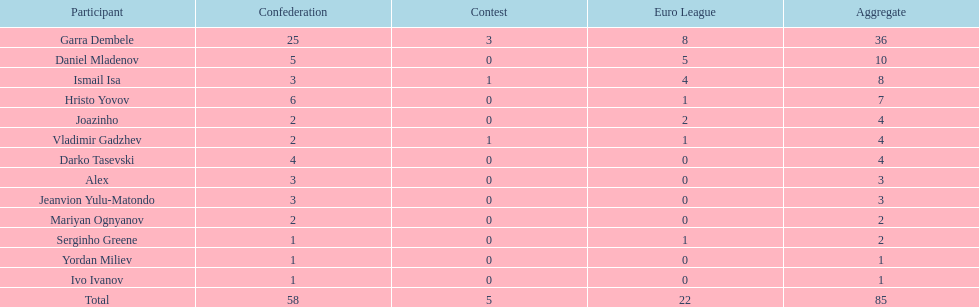How many players did not score a goal in cup play? 10. Give me the full table as a dictionary. {'header': ['Participant', 'Confederation', 'Contest', 'Euro League', 'Aggregate'], 'rows': [['Garra Dembele', '25', '3', '8', '36'], ['Daniel Mladenov', '5', '0', '5', '10'], ['Ismail Isa', '3', '1', '4', '8'], ['Hristo Yovov', '6', '0', '1', '7'], ['Joazinho', '2', '0', '2', '4'], ['Vladimir Gadzhev', '2', '1', '1', '4'], ['Darko Tasevski', '4', '0', '0', '4'], ['Alex', '3', '0', '0', '3'], ['Jeanvion Yulu-Matondo', '3', '0', '0', '3'], ['Mariyan Ognyanov', '2', '0', '0', '2'], ['Serginho Greene', '1', '0', '1', '2'], ['Yordan Miliev', '1', '0', '0', '1'], ['Ivo Ivanov', '1', '0', '0', '1'], ['Total', '58', '5', '22', '85']]} 